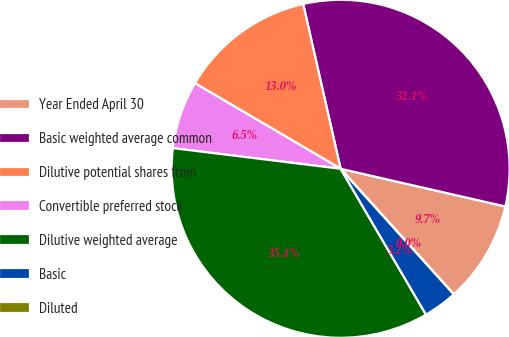Convert chart to OTSL. <chart><loc_0><loc_0><loc_500><loc_500><pie_chart><fcel>Year Ended April 30<fcel>Basic weighted average common<fcel>Dilutive potential shares from<fcel>Convertible preferred stock<fcel>Dilutive weighted average<fcel>Basic<fcel>Diluted<nl><fcel>9.74%<fcel>32.14%<fcel>12.99%<fcel>6.5%<fcel>35.38%<fcel>3.25%<fcel>0.0%<nl></chart> 